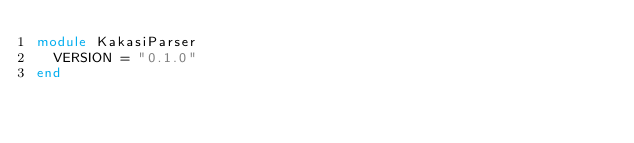Convert code to text. <code><loc_0><loc_0><loc_500><loc_500><_Ruby_>module KakasiParser
  VERSION = "0.1.0"
end
</code> 